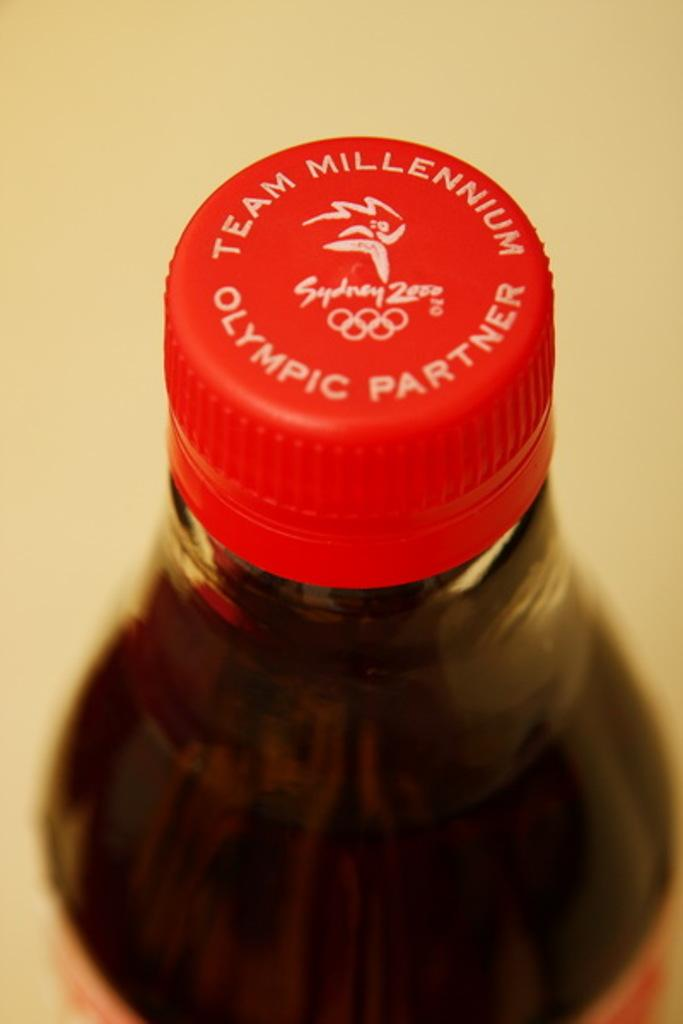Provide a one-sentence caption for the provided image. An up close image of a red bottle cap with the words Olympic Partner written on the top of it. 